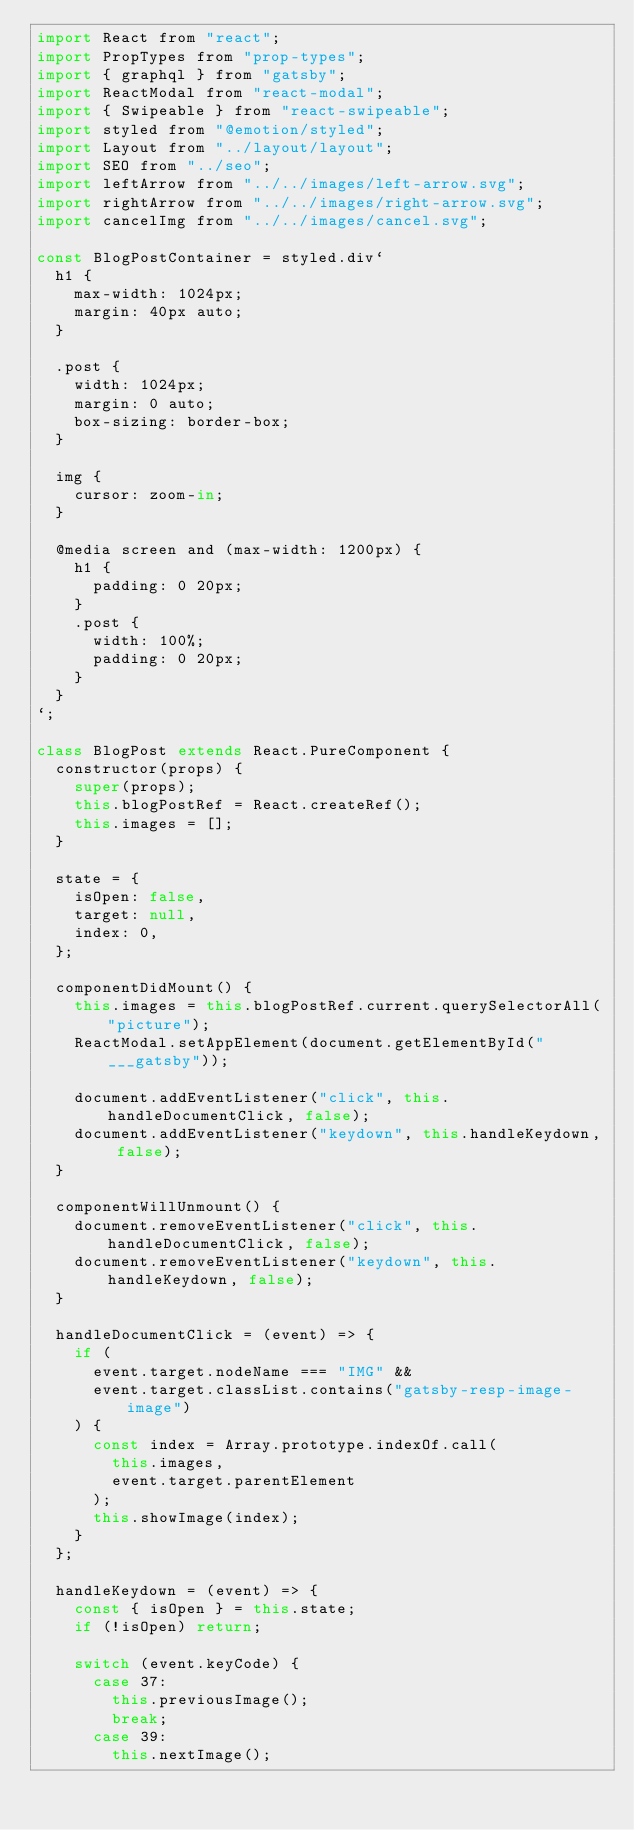Convert code to text. <code><loc_0><loc_0><loc_500><loc_500><_JavaScript_>import React from "react";
import PropTypes from "prop-types";
import { graphql } from "gatsby";
import ReactModal from "react-modal";
import { Swipeable } from "react-swipeable";
import styled from "@emotion/styled";
import Layout from "../layout/layout";
import SEO from "../seo";
import leftArrow from "../../images/left-arrow.svg";
import rightArrow from "../../images/right-arrow.svg";
import cancelImg from "../../images/cancel.svg";

const BlogPostContainer = styled.div`
  h1 {
    max-width: 1024px;
    margin: 40px auto;
  }

  .post {
    width: 1024px;
    margin: 0 auto;
    box-sizing: border-box;
  }

  img {
    cursor: zoom-in;
  }

  @media screen and (max-width: 1200px) {
    h1 {
      padding: 0 20px;
    }
    .post {
      width: 100%;
      padding: 0 20px;
    }
  }
`;

class BlogPost extends React.PureComponent {
  constructor(props) {
    super(props);
    this.blogPostRef = React.createRef();
    this.images = [];
  }

  state = {
    isOpen: false,
    target: null,
    index: 0,
  };

  componentDidMount() {
    this.images = this.blogPostRef.current.querySelectorAll("picture");
    ReactModal.setAppElement(document.getElementById("___gatsby"));

    document.addEventListener("click", this.handleDocumentClick, false);
    document.addEventListener("keydown", this.handleKeydown, false);
  }

  componentWillUnmount() {
    document.removeEventListener("click", this.handleDocumentClick, false);
    document.removeEventListener("keydown", this.handleKeydown, false);
  }

  handleDocumentClick = (event) => {
    if (
      event.target.nodeName === "IMG" &&
      event.target.classList.contains("gatsby-resp-image-image")
    ) {
      const index = Array.prototype.indexOf.call(
        this.images,
        event.target.parentElement
      );
      this.showImage(index);
    }
  };

  handleKeydown = (event) => {
    const { isOpen } = this.state;
    if (!isOpen) return;

    switch (event.keyCode) {
      case 37:
        this.previousImage();
        break;
      case 39:
        this.nextImage();</code> 